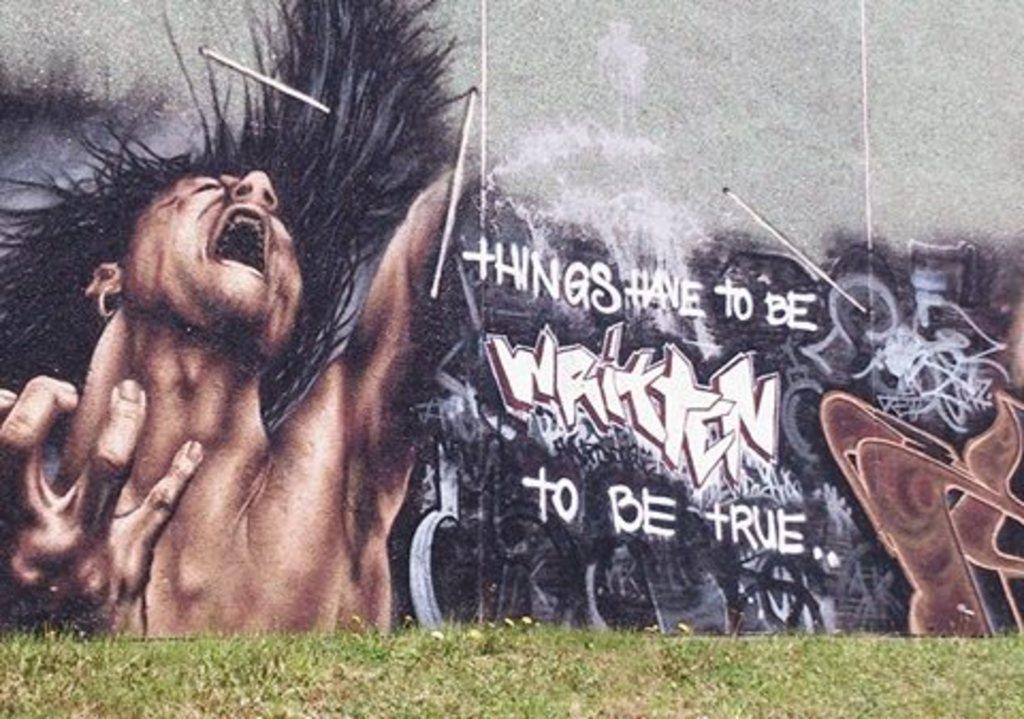What are the words on the board?
Make the answer very short. Things have to be written to be true. What does the graffiti say?
Give a very brief answer. Things have to be written to be true. 